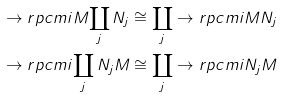Convert formula to latex. <formula><loc_0><loc_0><loc_500><loc_500>\to r p c m i { M } { \coprod _ { j } N _ { j } } & \cong \coprod _ { j } \to r p c m i { M } { N _ { j } } \\ \to r p c m i { \coprod _ { j } N _ { j } } { M } & \cong \coprod _ { j } \to r p c m i { N _ { j } } { M }</formula> 